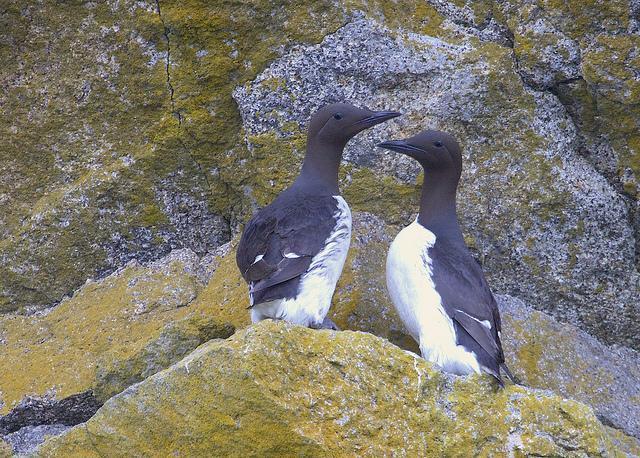How many birds are there?
Give a very brief answer. 2. How many birds are in the picture?
Give a very brief answer. 2. 